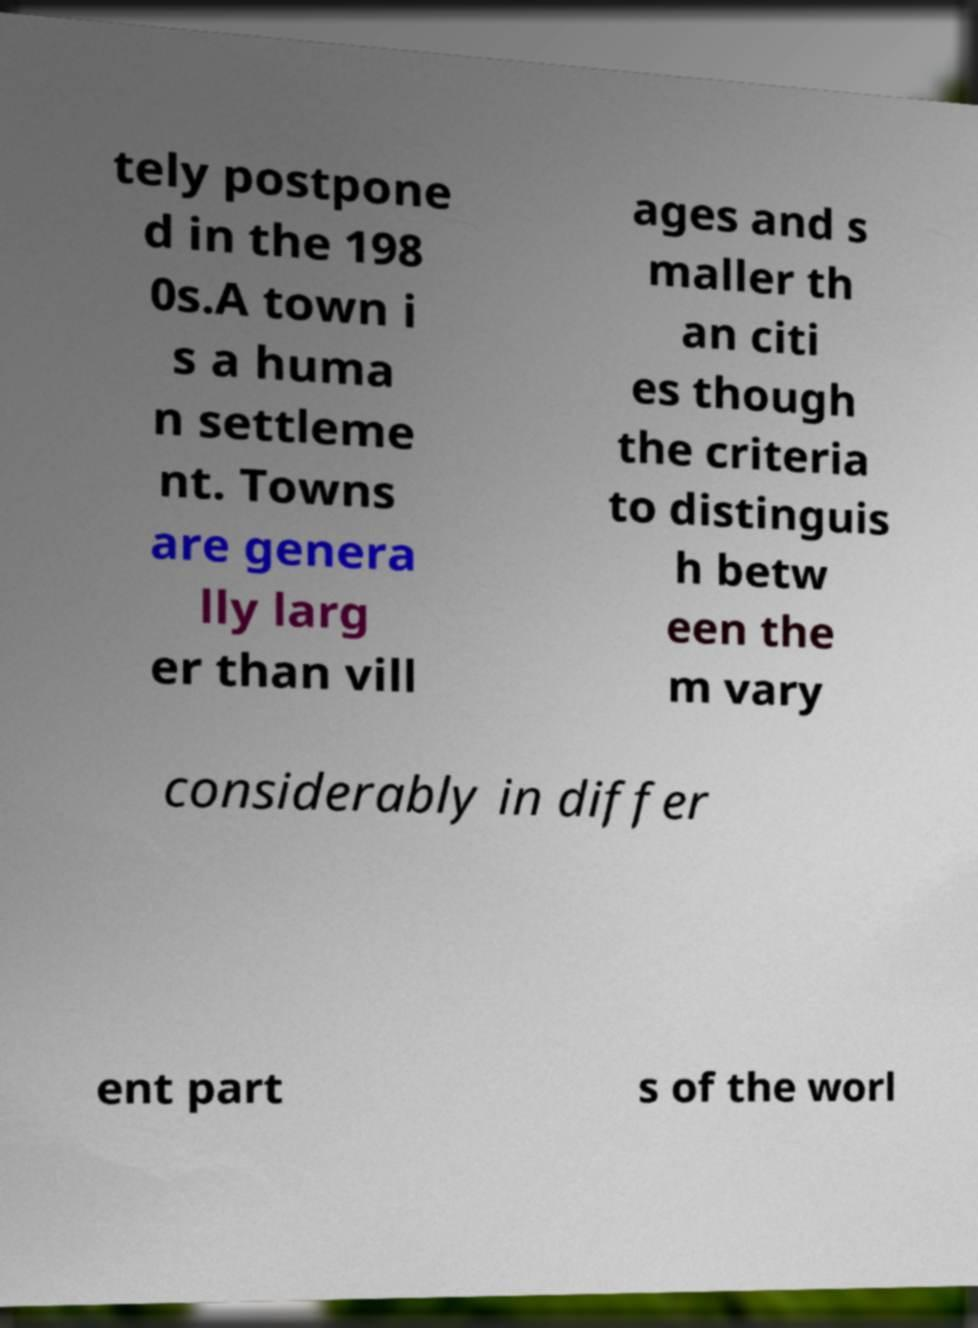Can you accurately transcribe the text from the provided image for me? tely postpone d in the 198 0s.A town i s a huma n settleme nt. Towns are genera lly larg er than vill ages and s maller th an citi es though the criteria to distinguis h betw een the m vary considerably in differ ent part s of the worl 